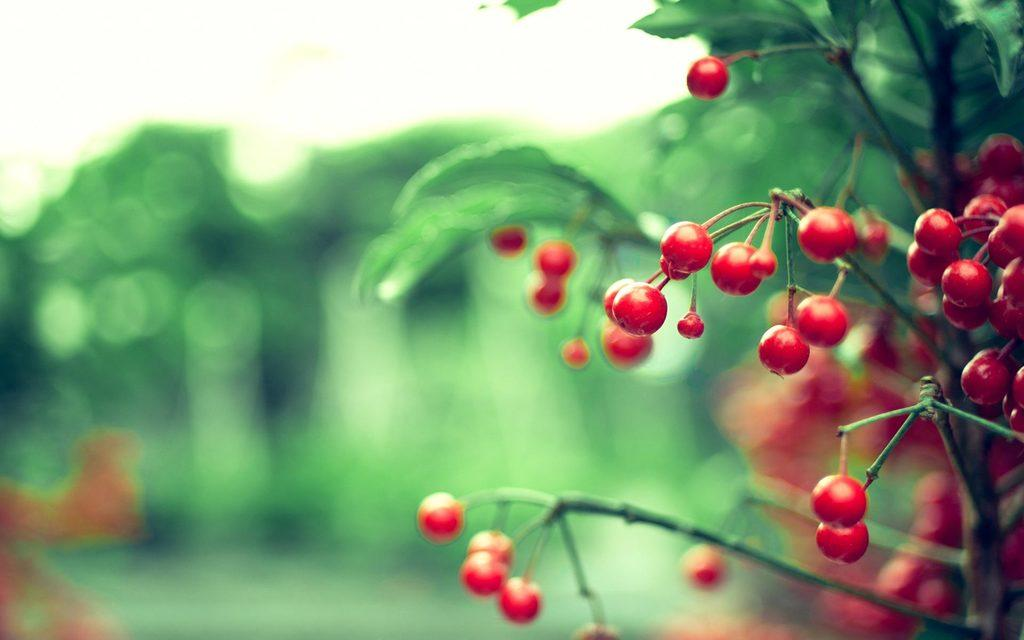What is the main subject of the image? The main subject of the image is a red color fruit plant. Can you describe the background of the image? The background of the image is blurry. How does the muscle in the image help the fruit plant grow? There is no muscle present in the image, as it features a red color fruit plant. 